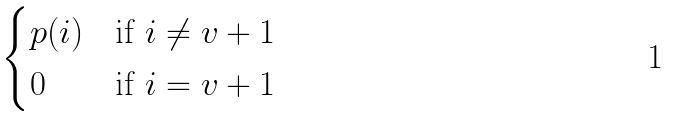Convert formula to latex. <formula><loc_0><loc_0><loc_500><loc_500>\begin{cases} p ( i ) & \text {if } i \neq v + 1 \\ 0 & \text {if } i = v + 1 \\ \end{cases}</formula> 